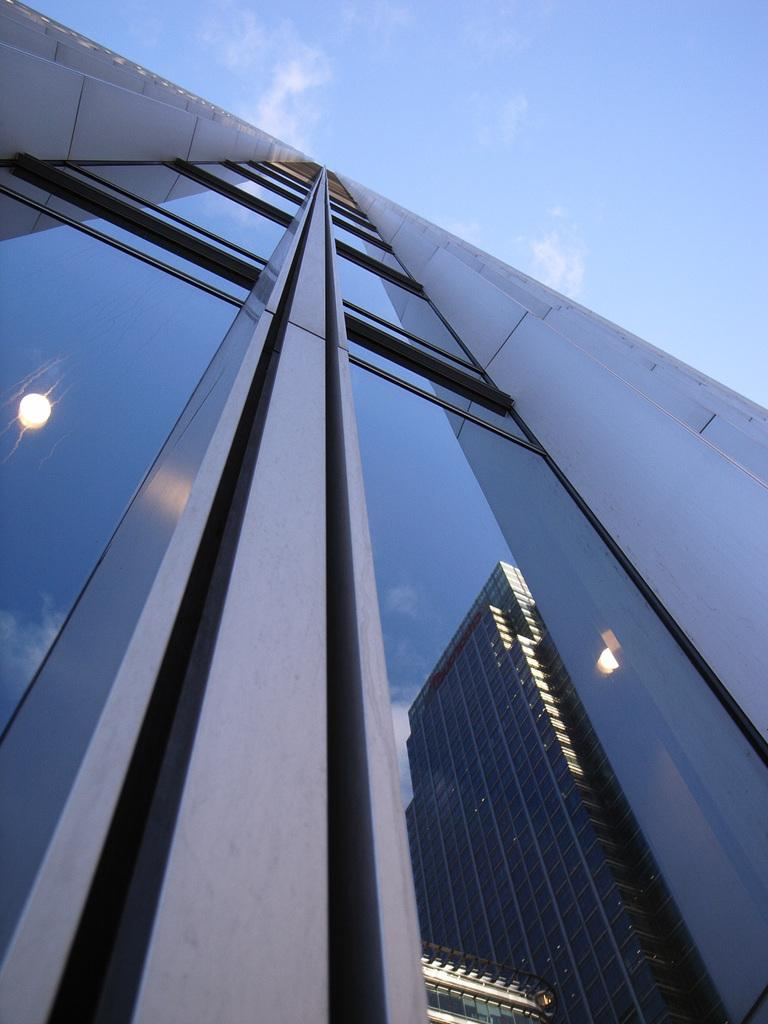What type of structure is present in the image? There is a building in the image. What material is the building primarily made of? The building is made up of glass. What can be seen reflected on the glass surface of the building? There is a reflection of another building on the glass. What is the condition of the glass surface in the image? There is light visible on the glass. What is the color of the sky in the image? The sky is pale blue in the image. What type of seat can be seen in the image? There is no seat present in the image; it primarily features a glass building and its surroundings. 